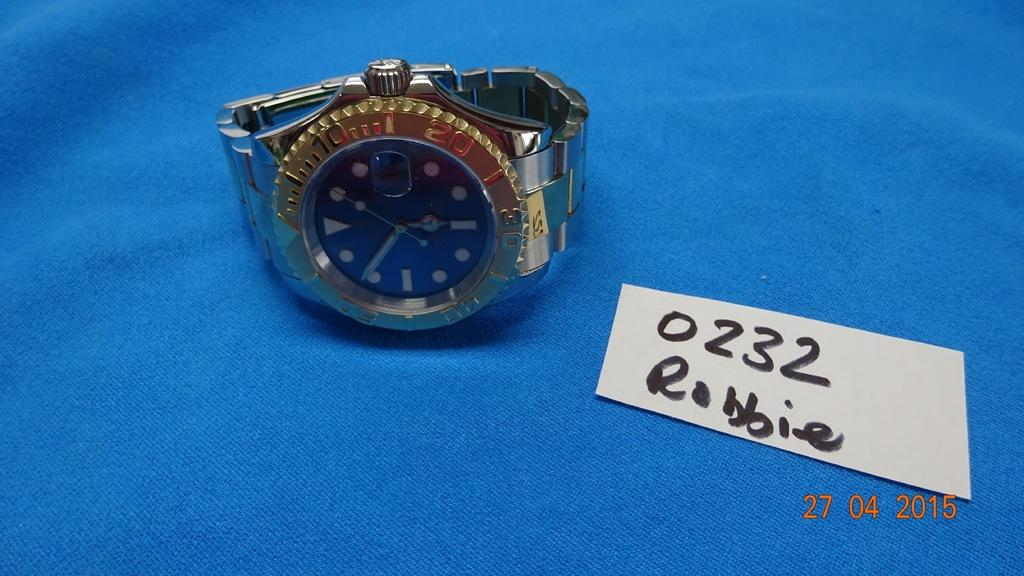<image>
Share a concise interpretation of the image provided. the numbers 0232 that is on a white paper 